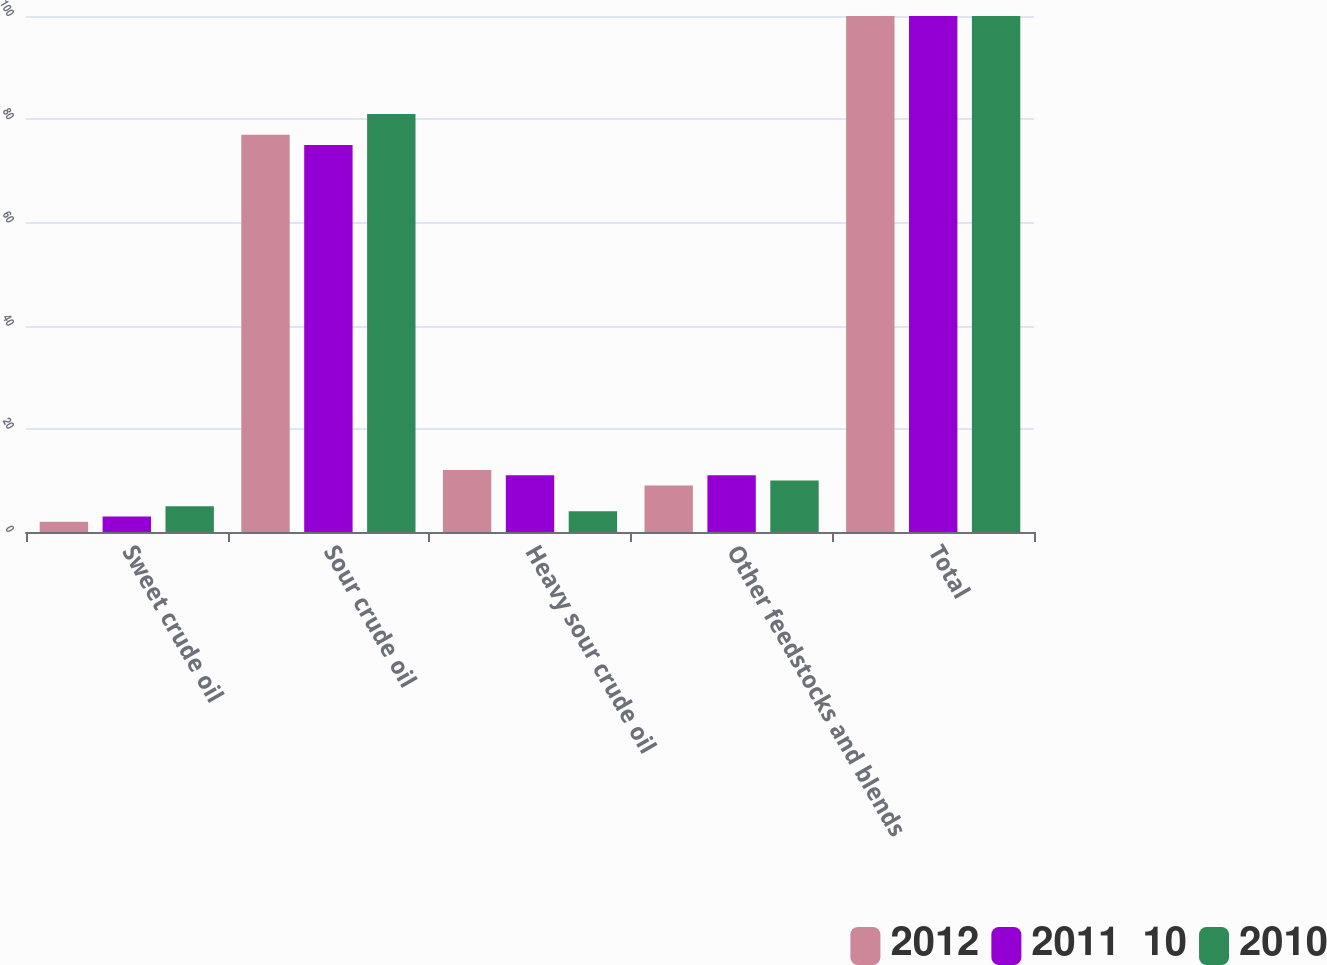<chart> <loc_0><loc_0><loc_500><loc_500><stacked_bar_chart><ecel><fcel>Sweet crude oil<fcel>Sour crude oil<fcel>Heavy sour crude oil<fcel>Other feedstocks and blends<fcel>Total<nl><fcel>2012<fcel>2<fcel>77<fcel>12<fcel>9<fcel>100<nl><fcel>2011  10<fcel>3<fcel>75<fcel>11<fcel>11<fcel>100<nl><fcel>2010<fcel>5<fcel>81<fcel>4<fcel>10<fcel>100<nl></chart> 